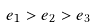Convert formula to latex. <formula><loc_0><loc_0><loc_500><loc_500>e _ { 1 } > e _ { 2 } > e _ { 3 }</formula> 